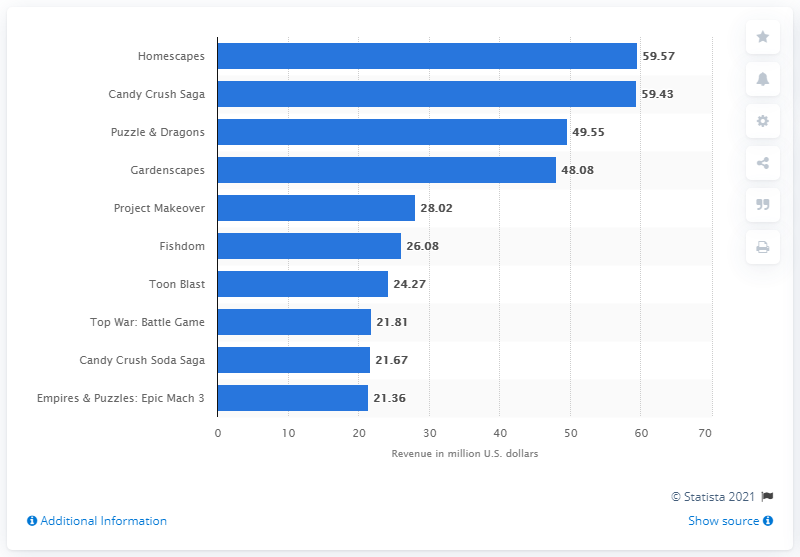Draw attention to some important aspects in this diagram. The second-ranked game generated 59.43 million U.S. dollars in monthly in-app purchases (IAP) revenue. This game was Candy Crush Saga. We know that the top-grossing puzzle game worldwide in February 2021 was Homescapes. Homescapes generated approximately 59.57 million dollars through in-app purchases. 